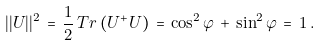Convert formula to latex. <formula><loc_0><loc_0><loc_500><loc_500>| | U | | ^ { 2 } \, = \, \frac { 1 } { 2 } \, T r \left ( U ^ { + } U \right ) \, = \, \cos ^ { 2 } \varphi \, + \, \sin ^ { 2 } \varphi \, = \, 1 \, .</formula> 